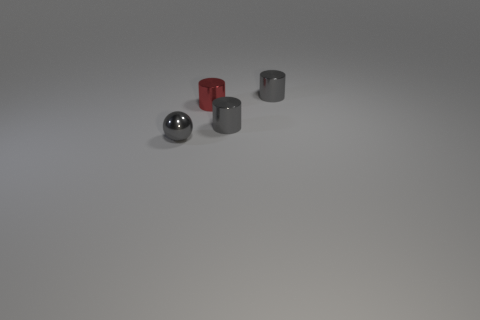Is there a small shiny cylinder that has the same color as the tiny sphere?
Make the answer very short. Yes. Are there more gray shiny things in front of the tiny red cylinder than small shiny spheres?
Provide a succinct answer. Yes. There is a tiny red metallic thing; is its shape the same as the tiny object behind the red metallic cylinder?
Your answer should be compact. Yes. Are any red things visible?
Keep it short and to the point. Yes. How many small things are spheres or metal objects?
Offer a terse response. 4. Is the number of gray metal cylinders that are in front of the small red metal cylinder greater than the number of tiny gray metallic things to the right of the gray ball?
Your answer should be very brief. No. What color is the small sphere?
Your answer should be very brief. Gray. The metallic object that is behind the tiny red shiny thing has what shape?
Offer a terse response. Cylinder. How many cyan things are either small cylinders or tiny balls?
Your response must be concise. 0. What is the color of the tiny ball that is the same material as the red cylinder?
Give a very brief answer. Gray. 